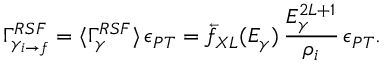<formula> <loc_0><loc_0><loc_500><loc_500>\Gamma _ { \gamma _ { i \rightarrow f } } ^ { R S F } = \langle \Gamma _ { \gamma } ^ { R S F } \rangle \, \epsilon _ { P T } = \overleftarrow { f } _ { X L } ( E _ { \gamma } ) \, \frac { E _ { \gamma } ^ { 2 L + 1 } } { \rho _ { i } } \, \epsilon _ { P T } .</formula> 